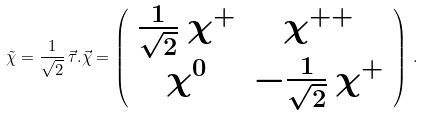<formula> <loc_0><loc_0><loc_500><loc_500>\tilde { \chi } = \frac { 1 } { \sqrt { 2 } } \, \vec { \tau } . \vec { \chi } = \left ( \begin{array} { c c } \frac { 1 } { \sqrt { 2 } } \, \chi ^ { + } & \chi ^ { + + } \\ \chi ^ { 0 } & - \frac { 1 } { \sqrt { 2 } } \, \chi ^ { + } \end{array} \right ) \, .</formula> 